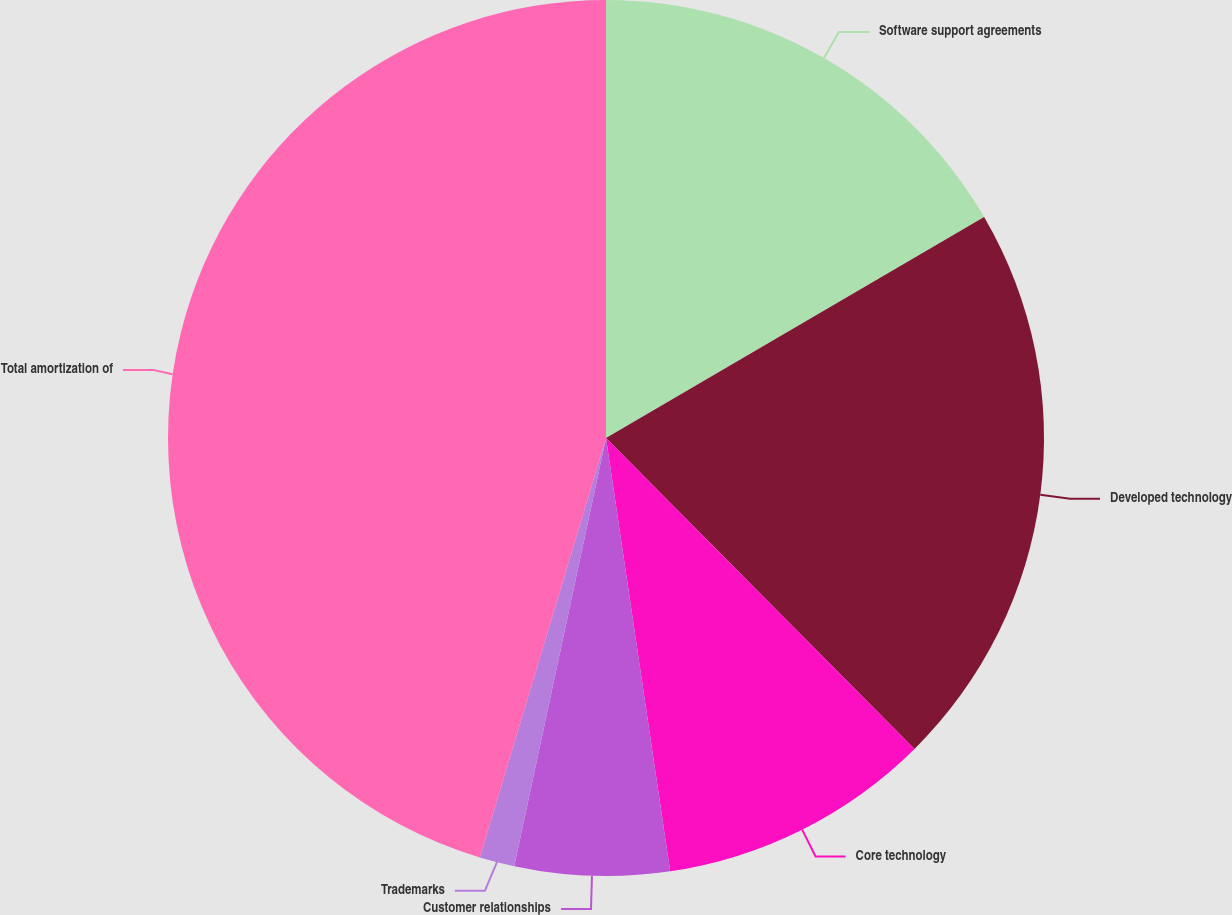<chart> <loc_0><loc_0><loc_500><loc_500><pie_chart><fcel>Software support agreements<fcel>Developed technology<fcel>Core technology<fcel>Customer relationships<fcel>Trademarks<fcel>Total amortization of<nl><fcel>16.58%<fcel>20.98%<fcel>10.1%<fcel>5.7%<fcel>1.29%<fcel>45.35%<nl></chart> 